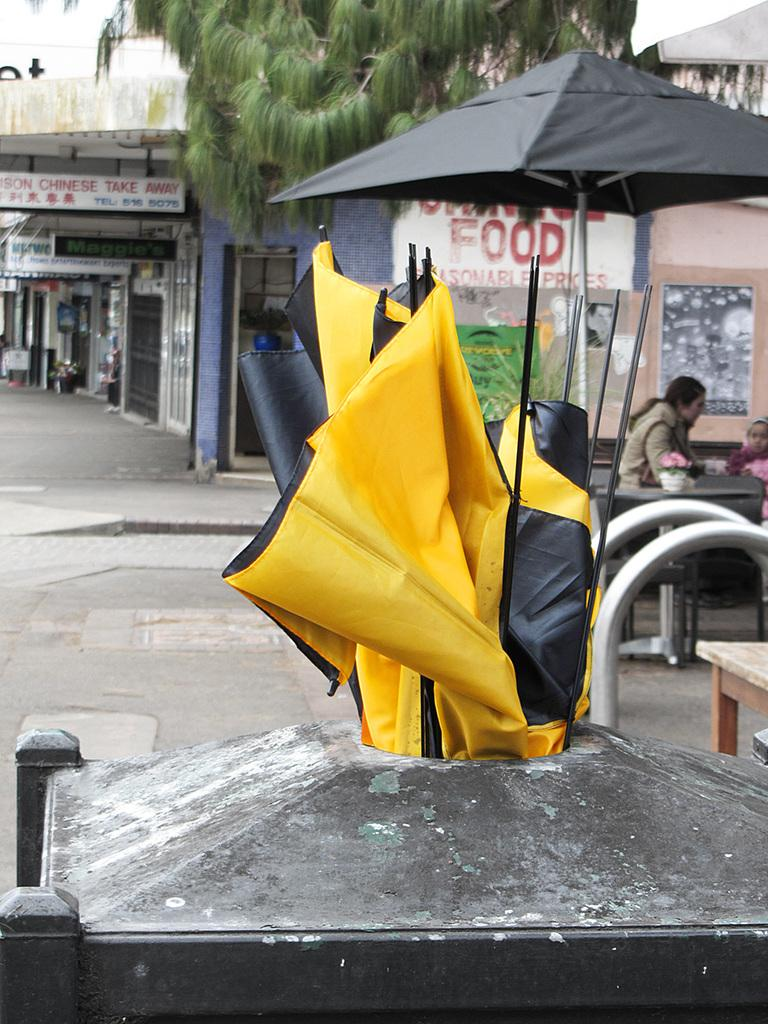What type of structures can be seen in the image? There are buildings in the image. What other objects can be seen in the image? There are boards, trees, posters, an umbrella, and tables in the image. How many people are present in the image? There are two persons in the image. What color objects can be seen in the image? There are yellow color objects in the image. What type of jeans is the church wearing in the image? There is no church or jeans present in the image. How many arms can be seen on the person in the image? There is no specific person mentioned in the provided facts, so it is impossible to determine the number of arms visible in the image. 